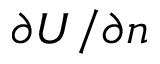Convert formula to latex. <formula><loc_0><loc_0><loc_500><loc_500>\partial U / \partial n</formula> 